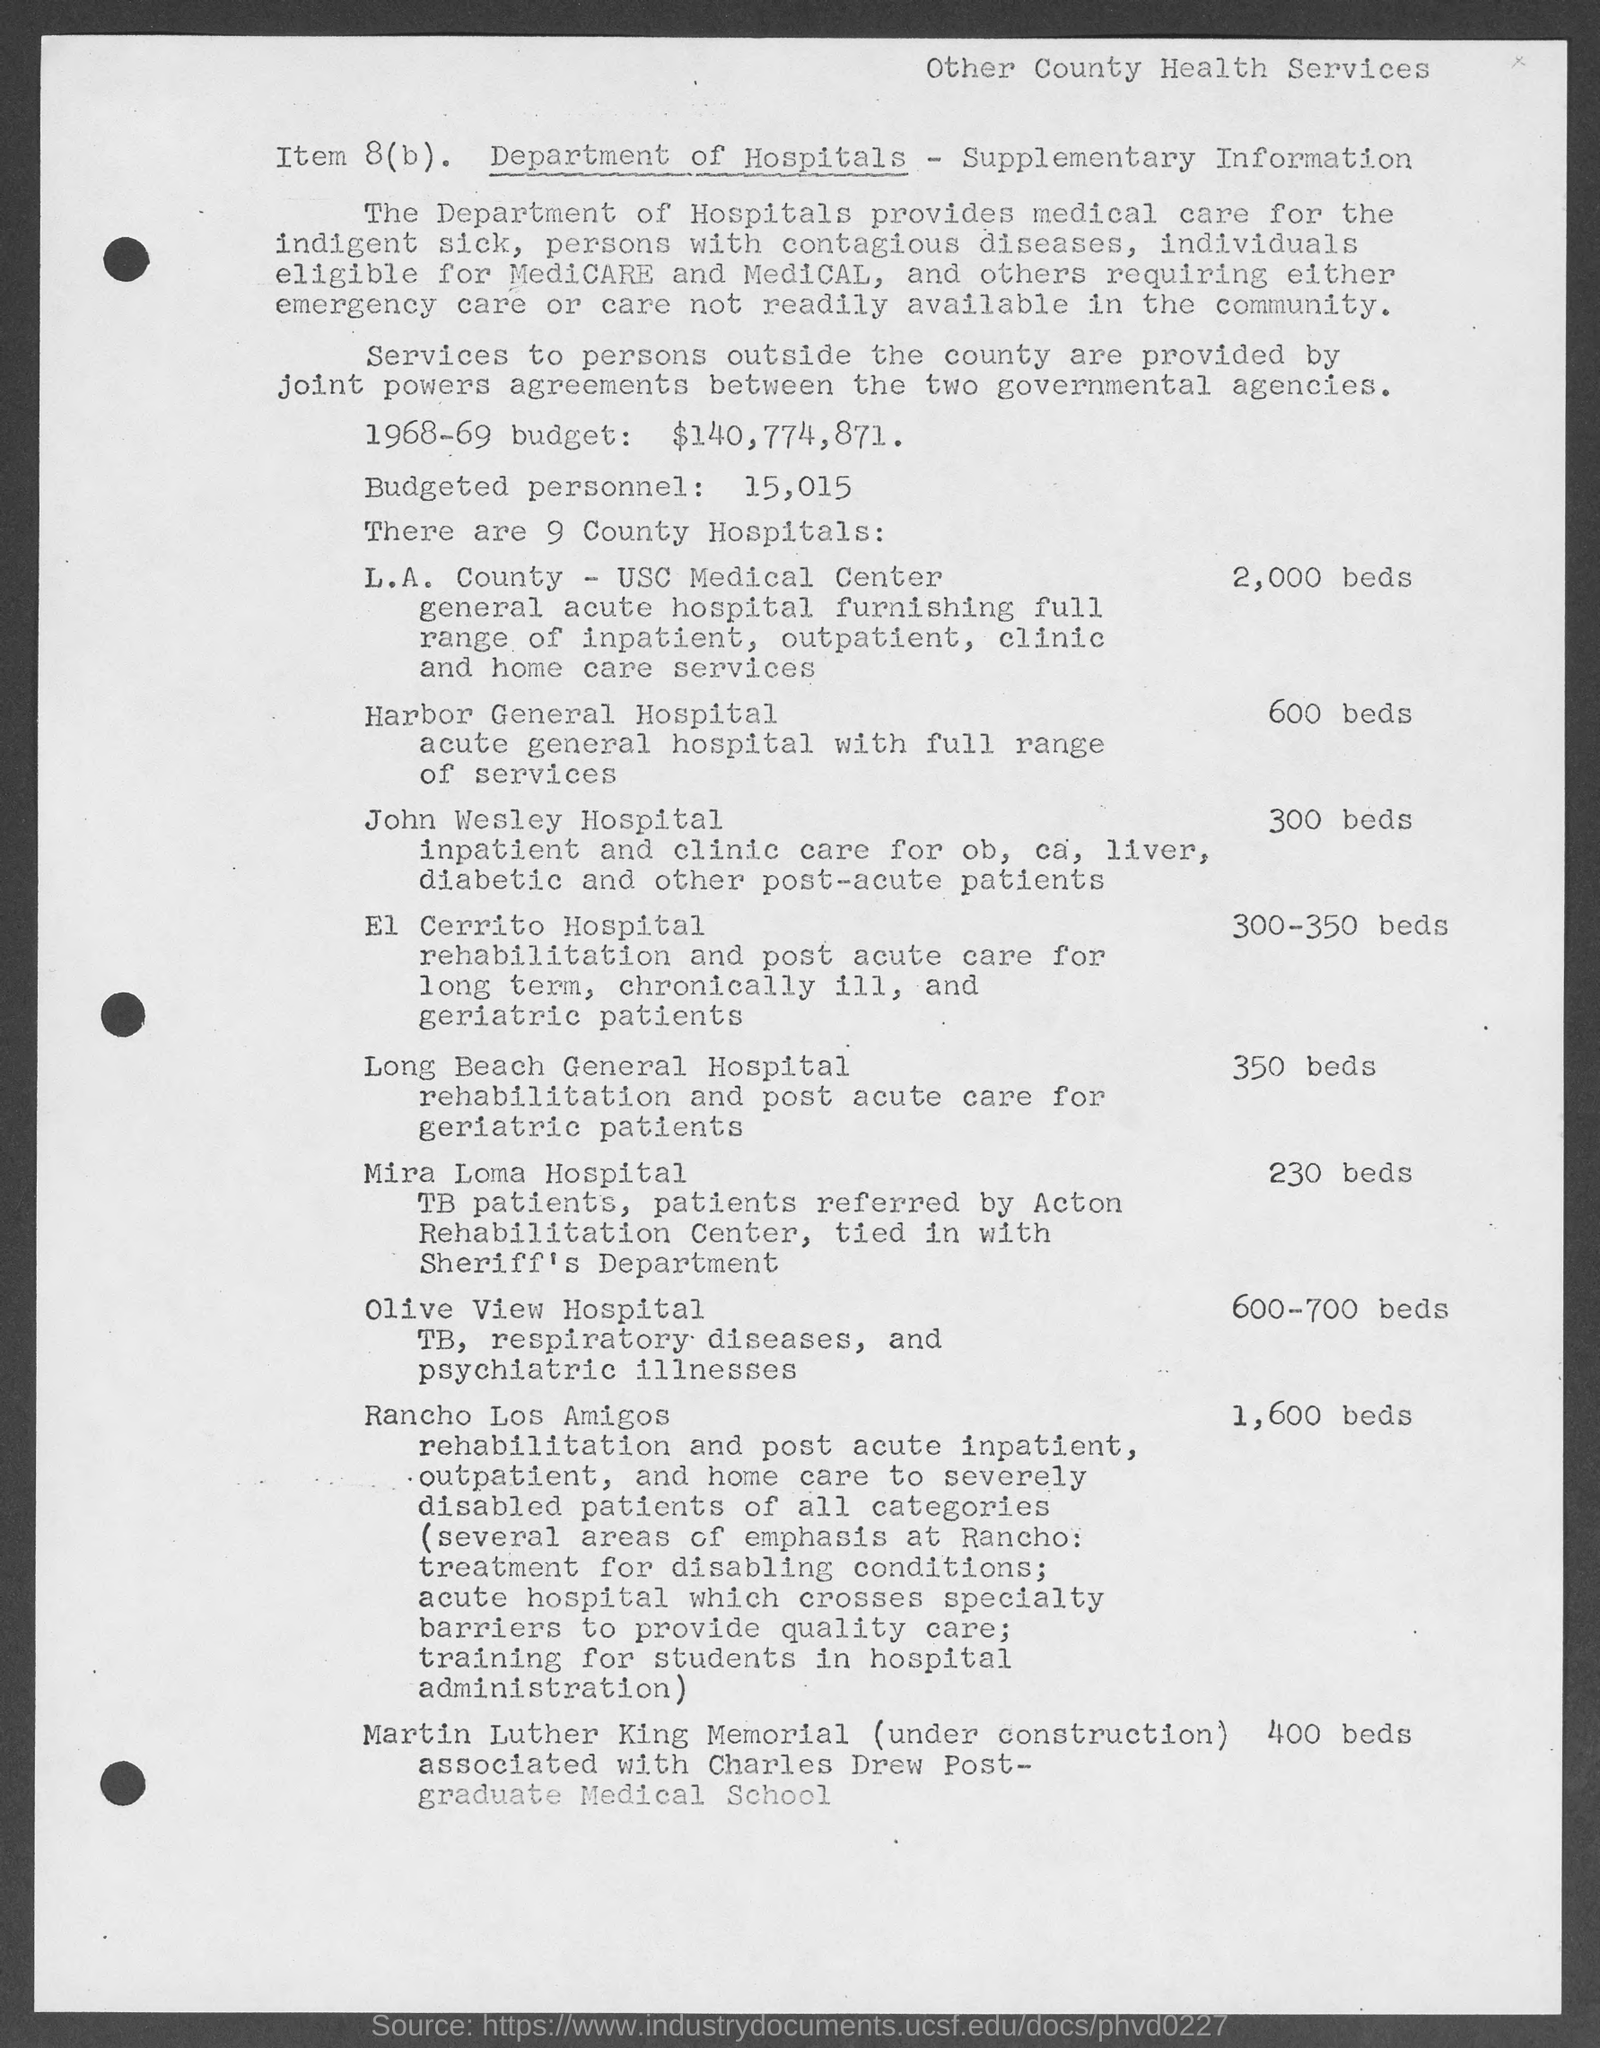How many beds are available in L.A. County - USC Medical Center?
Your answer should be compact. 2,000. How many beds are available in Harbor General Hospital?
Your response must be concise. 600. 